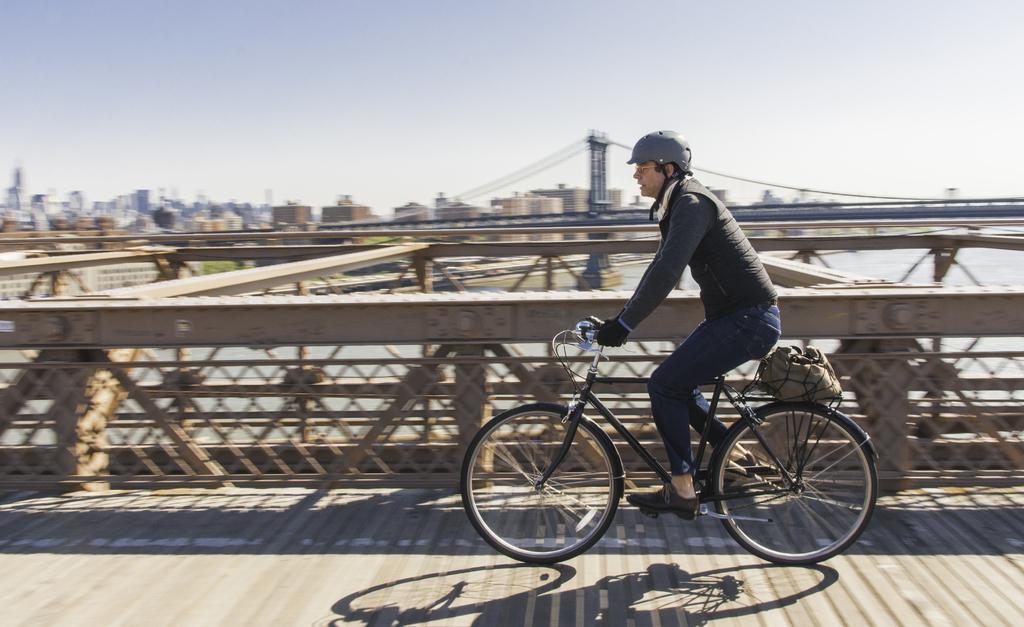Describe this image in one or two sentences. In this picture a man riding a bicycle on the bridge and we see some buildings and water 